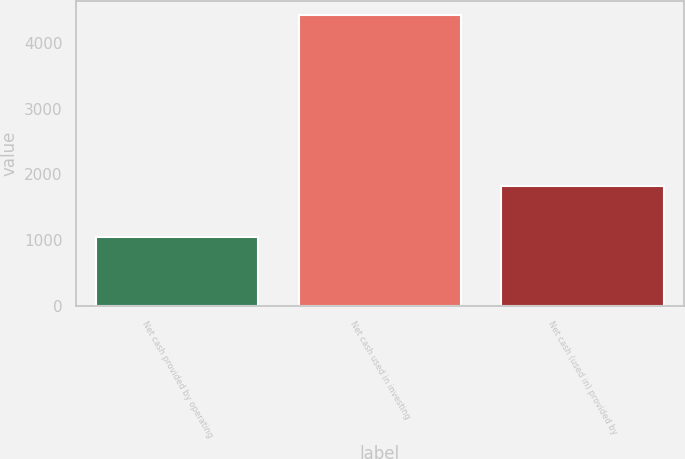Convert chart. <chart><loc_0><loc_0><loc_500><loc_500><bar_chart><fcel>Net cash provided by operating<fcel>Net cash used in investing<fcel>Net cash (used in) provided by<nl><fcel>1052<fcel>4421<fcel>1830<nl></chart> 